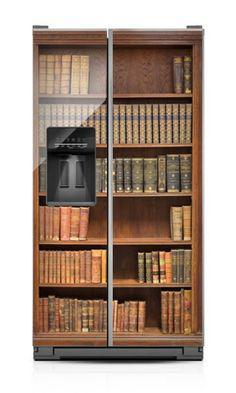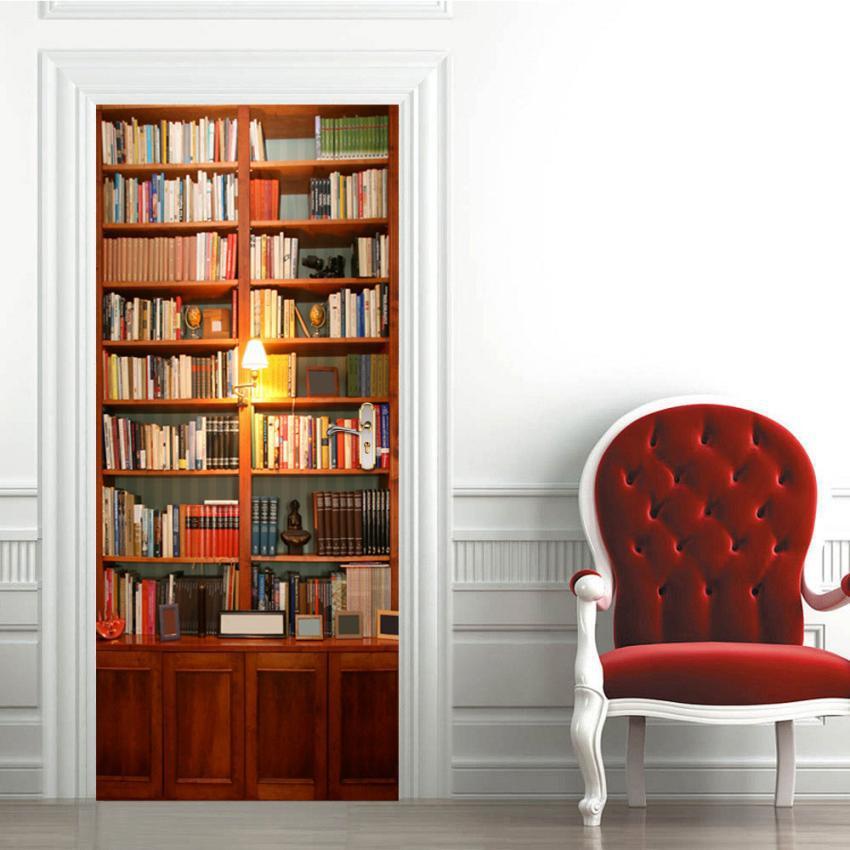The first image is the image on the left, the second image is the image on the right. Considering the images on both sides, is "there is a built in bookcase with white molding and molding on half the wall around it" valid? Answer yes or no. Yes. The first image is the image on the left, the second image is the image on the right. Examine the images to the left and right. Is the description "One of the bookshelves has wooden cabinet doors at the bottom." accurate? Answer yes or no. Yes. 